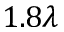<formula> <loc_0><loc_0><loc_500><loc_500>1 . 8 \lambda</formula> 